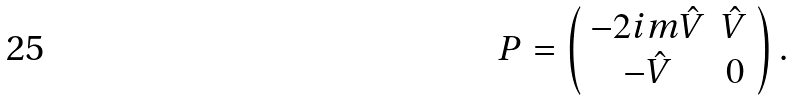<formula> <loc_0><loc_0><loc_500><loc_500>P = \left ( \begin{array} { c c } - 2 i m \hat { V } & \hat { V } \\ - \hat { V } & 0 \end{array} \right ) .</formula> 